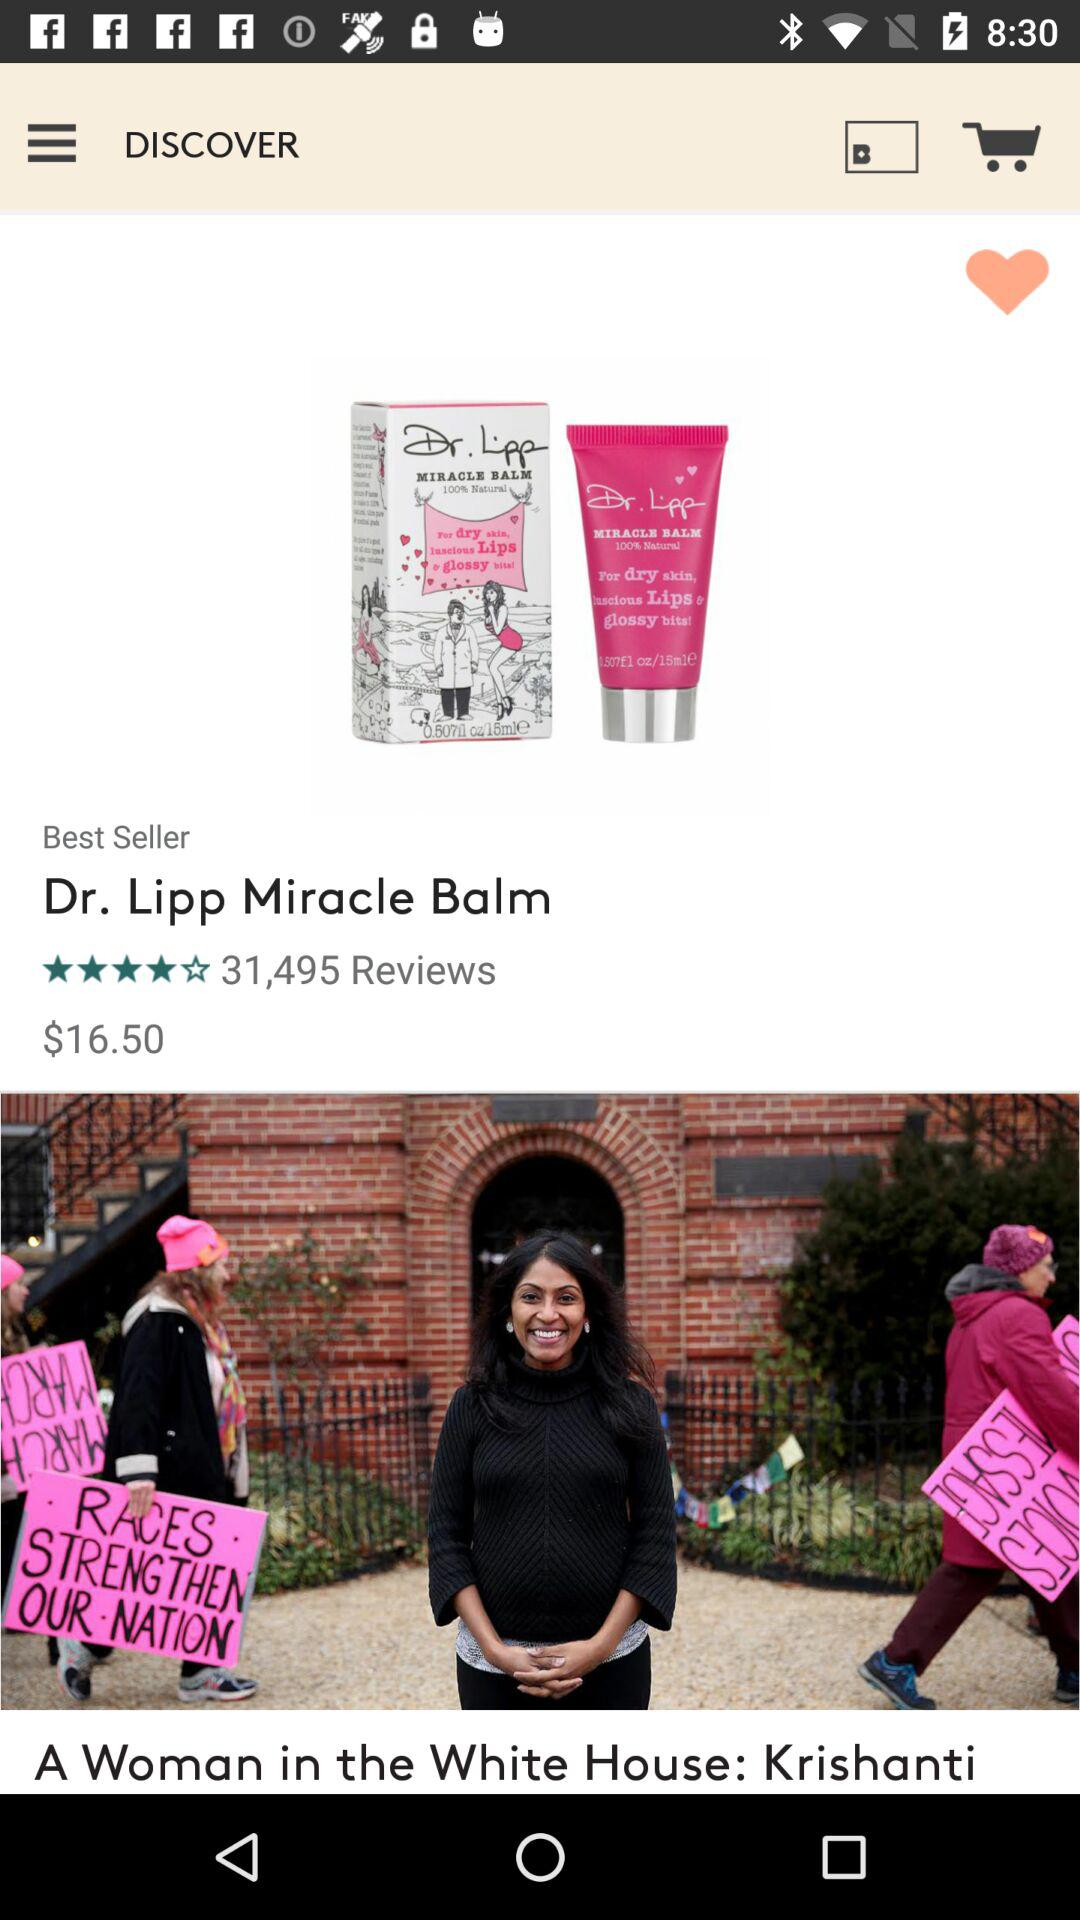What is the given rating? The given rating is 4 stars. 